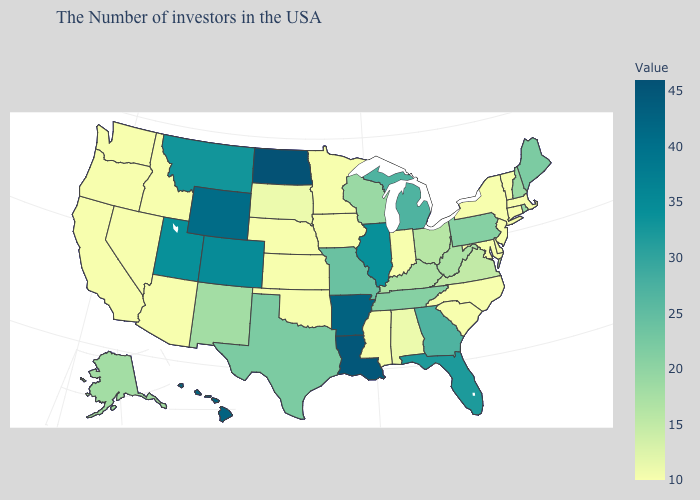Among the states that border Virginia , which have the highest value?
Answer briefly. Tennessee. Which states have the lowest value in the South?
Concise answer only. Delaware, Maryland, North Carolina, South Carolina, Mississippi, Oklahoma. Is the legend a continuous bar?
Write a very short answer. Yes. Does Wyoming have a lower value than California?
Answer briefly. No. 